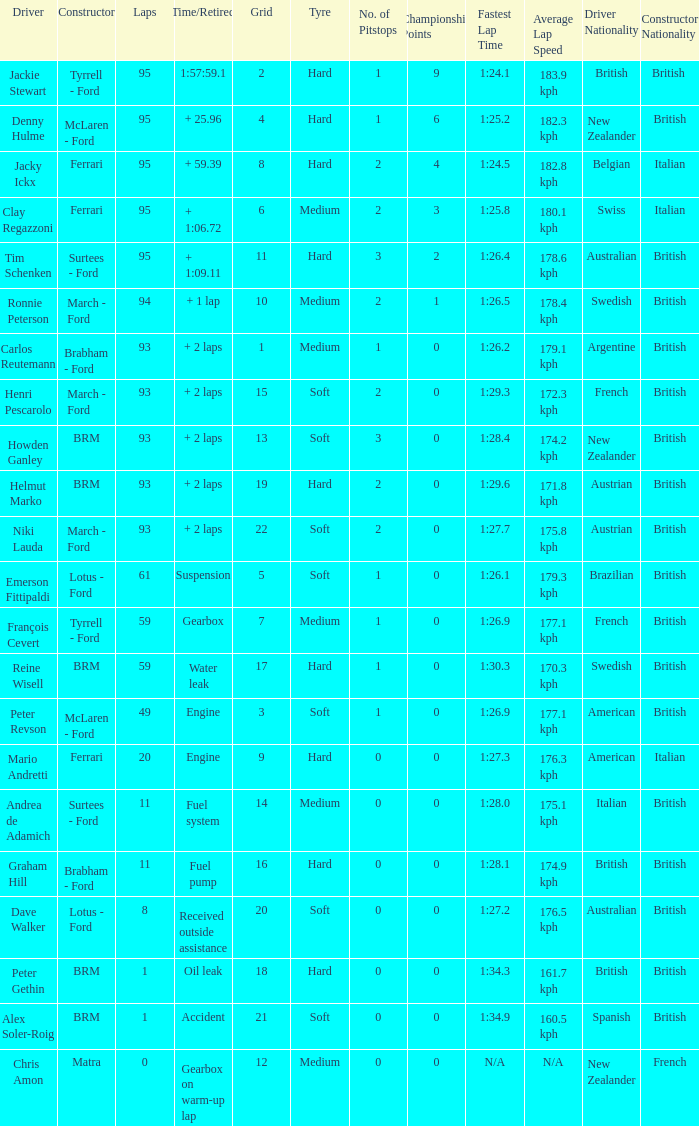Which grid has less than 11 laps, and a Time/Retired of accident? 21.0. 